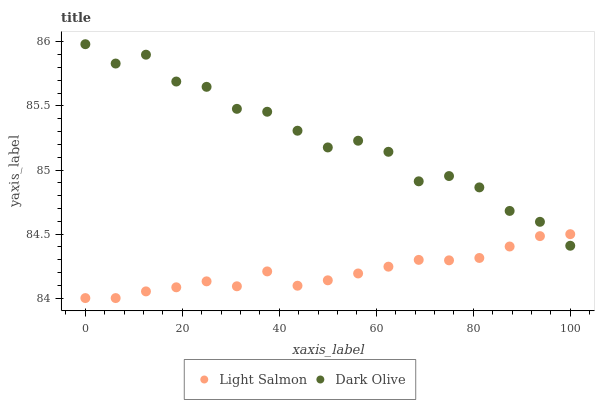Does Light Salmon have the minimum area under the curve?
Answer yes or no. Yes. Does Dark Olive have the maximum area under the curve?
Answer yes or no. Yes. Does Dark Olive have the minimum area under the curve?
Answer yes or no. No. Is Light Salmon the smoothest?
Answer yes or no. Yes. Is Dark Olive the roughest?
Answer yes or no. Yes. Is Dark Olive the smoothest?
Answer yes or no. No. Does Light Salmon have the lowest value?
Answer yes or no. Yes. Does Dark Olive have the lowest value?
Answer yes or no. No. Does Dark Olive have the highest value?
Answer yes or no. Yes. Does Dark Olive intersect Light Salmon?
Answer yes or no. Yes. Is Dark Olive less than Light Salmon?
Answer yes or no. No. Is Dark Olive greater than Light Salmon?
Answer yes or no. No. 